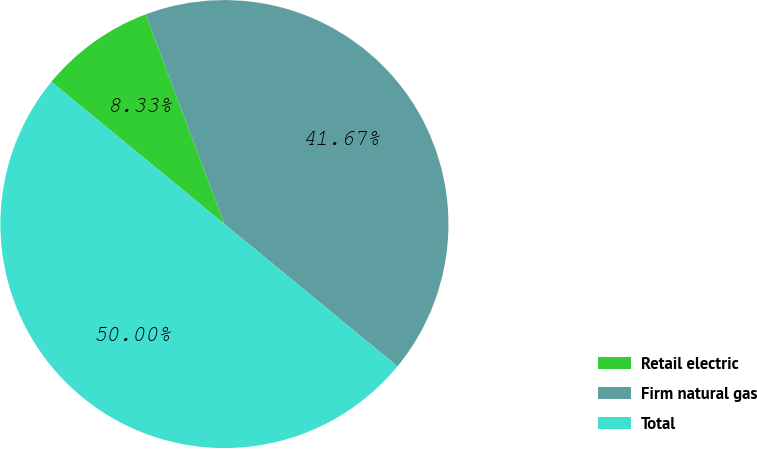Convert chart to OTSL. <chart><loc_0><loc_0><loc_500><loc_500><pie_chart><fcel>Retail electric<fcel>Firm natural gas<fcel>Total<nl><fcel>8.33%<fcel>41.67%<fcel>50.0%<nl></chart> 